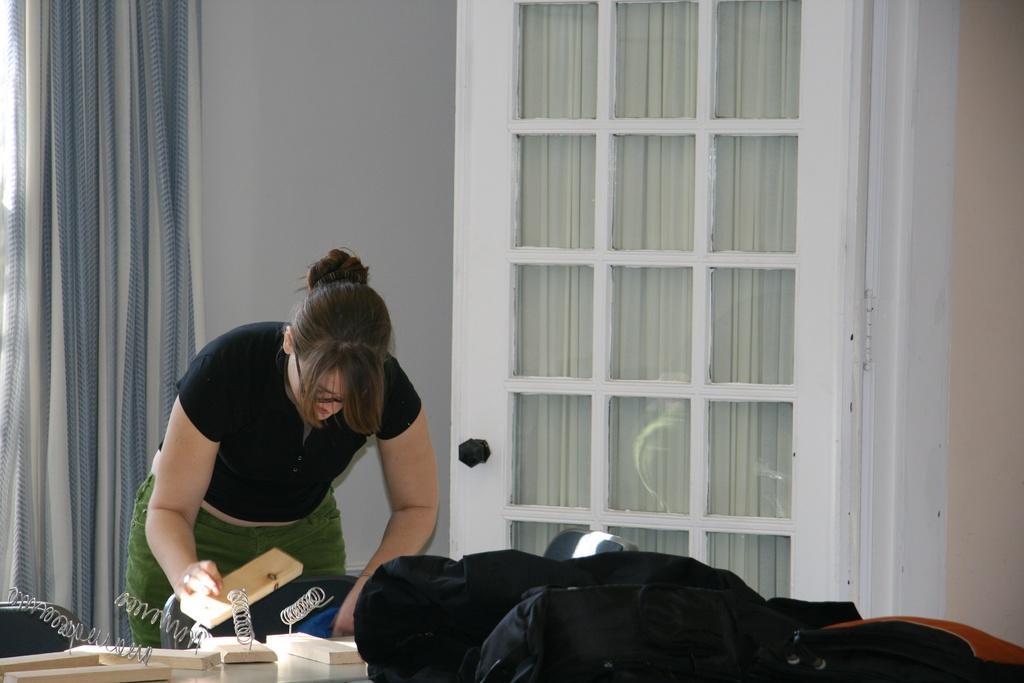Can you describe this image briefly? This image consists of a woman wearing black T-shirt. She is holding a wooden piece. In the front, there is a table on which bags are kept. In the background, there is a wall along with door and curtain. 